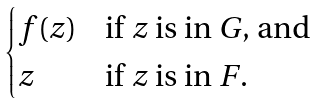<formula> <loc_0><loc_0><loc_500><loc_500>\begin{cases} f ( z ) & \text {if $z$ is in $G$, and } \\ z & \text {if $z$ is in $\mathbb{ }F$.} \end{cases}</formula> 